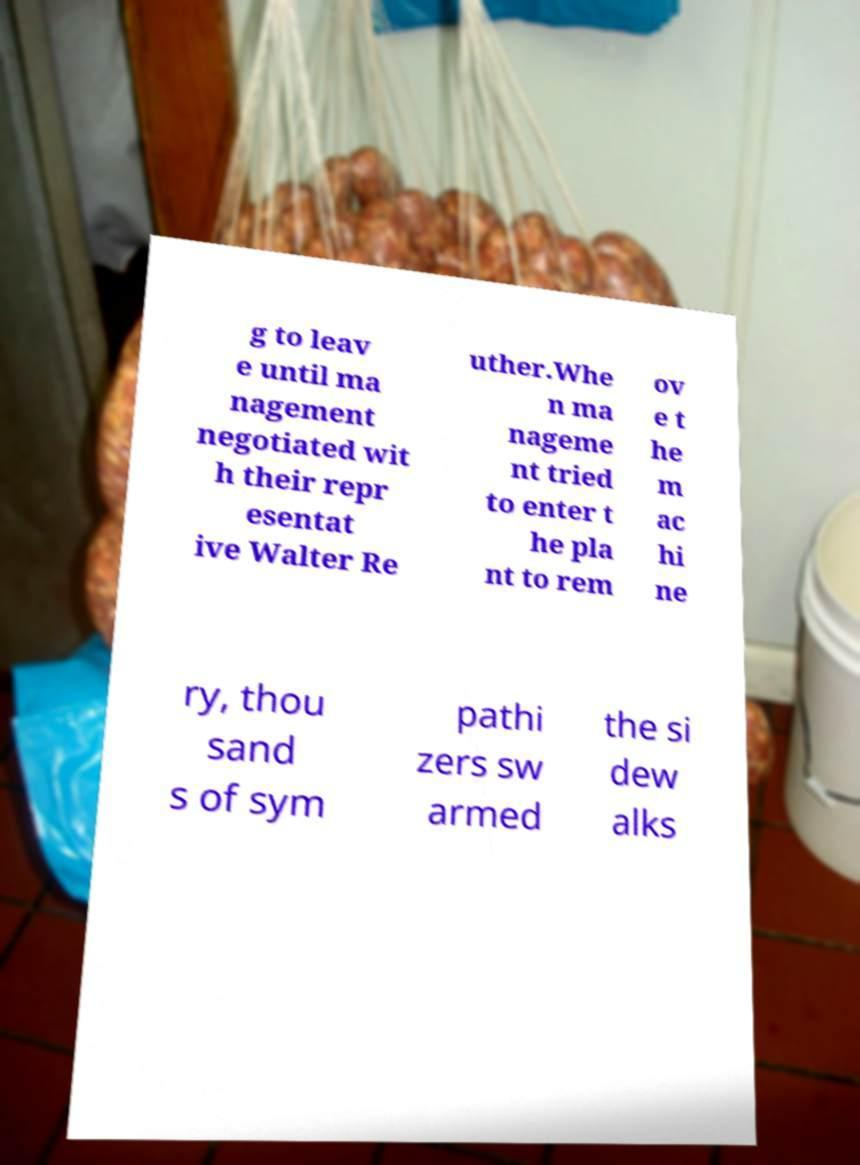I need the written content from this picture converted into text. Can you do that? g to leav e until ma nagement negotiated wit h their repr esentat ive Walter Re uther.Whe n ma nageme nt tried to enter t he pla nt to rem ov e t he m ac hi ne ry, thou sand s of sym pathi zers sw armed the si dew alks 